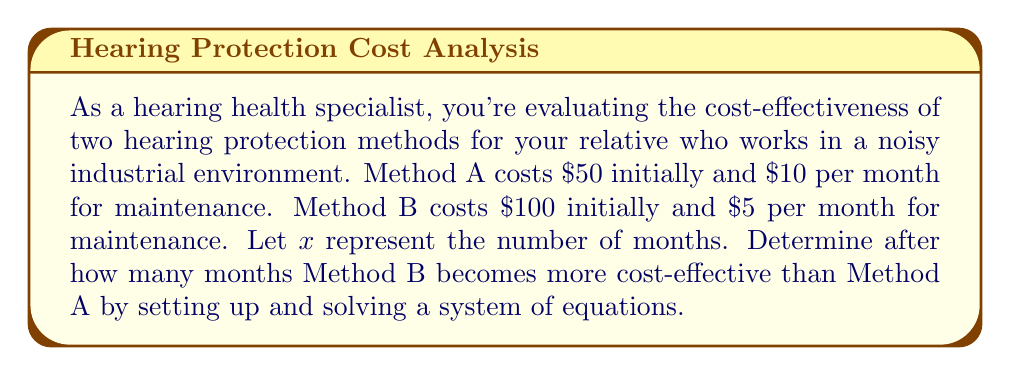Can you answer this question? Let's approach this step-by-step:

1) First, let's set up equations for the total cost of each method over $x$ months:

   Method A: $y_A = 50 + 10x$
   Method B: $y_B = 100 + 5x$

2) To find when Method B becomes more cost-effective, we need to find when the costs are equal:

   $y_A = y_B$
   $50 + 10x = 100 + 5x$

3) Now we have our system of equations:

   $$\begin{cases}
   y_A = 50 + 10x \\
   y_B = 100 + 5x \\
   50 + 10x = 100 + 5x
   \end{cases}$$

4) Let's solve the equality:

   $50 + 10x = 100 + 5x$
   $10x - 5x = 100 - 50$
   $5x = 50$

5) Solving for $x$:

   $x = 50 / 5 = 10$

6) Therefore, after 10 months, the costs will be equal. To verify:

   At 10 months:
   Method A: $50 + 10(10) = 150$
   Method B: $100 + 5(10) = 150$

7) After 10 months, Method B will be more cost-effective as its monthly cost is lower.
Answer: 10 months 